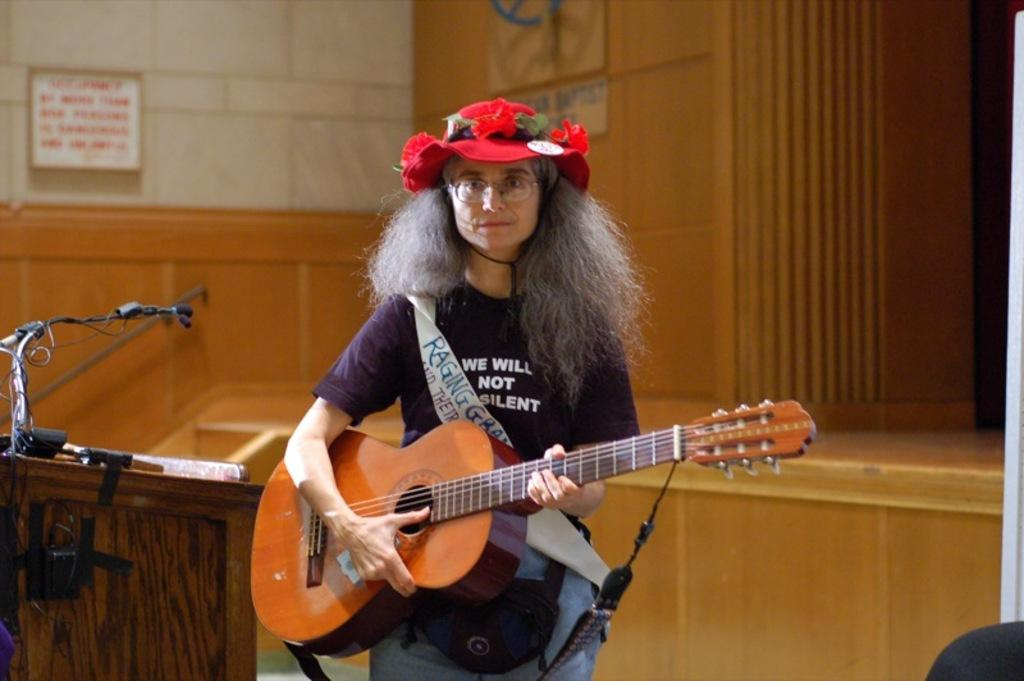What is the main subject of the image? The main subject of the image is a woman. What is the woman doing in the image? The woman is standing and playing a guitar. What other objects can be seen in the image? There is a podium and a microphone on the podium in the image. How many ladybugs can be seen on the guitar in the image? There are no ladybugs visible on the guitar in the image. What type of bell is hanging from the podium in the image? There is no bell present in the image; it only features a podium and a microphone on it. 